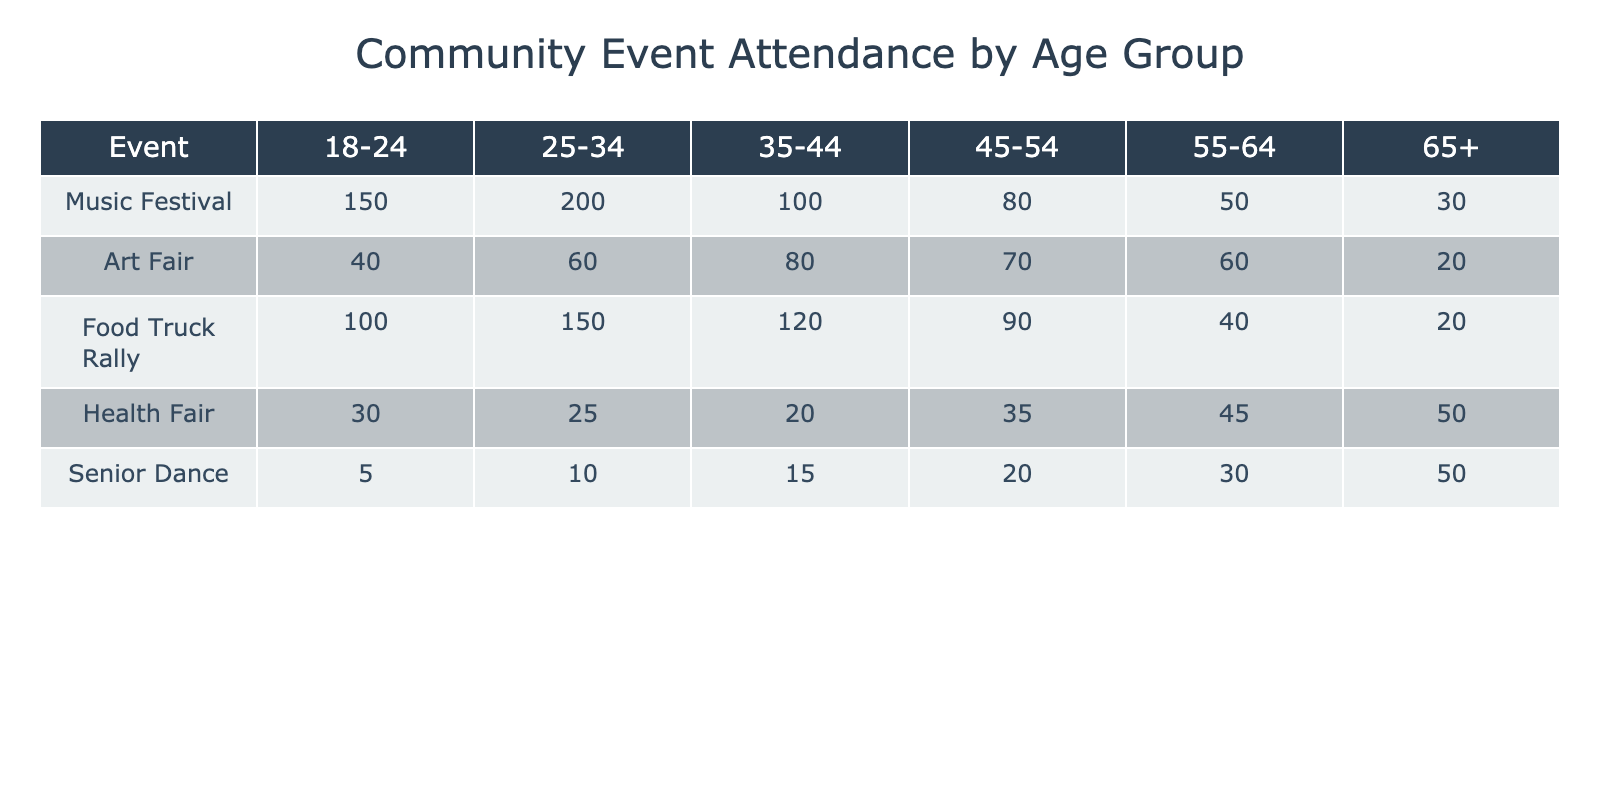What age group had the highest attendance at the Music Festival? Looking at the Music Festival column, the highest number is 200, which corresponds to the age group 25-34.
Answer: 25-34 How many attendees aged 45-54 participated in the Health Fair? The Health Fair column for the age group 45-54 shows an attendance of 35.
Answer: 35 What is the total attendance across all events for the age group 65+? By adding the values for the 65+ age group from all events: 30 + 20 + 20 + 50 + 50 = 170.
Answer: 170 Which event had the lowest attendance from the age group 18-24? In the 18-24 age group, the lowest attendance is for the Senior Dance with 5 attendees.
Answer: Senior Dance Did more people from the age group 55-64 attend the Food Truck Rally than the Art Fair? The Food Truck Rally attendance for 55-64 is 40, and for the Art Fair it is 60. Thus, 40 is less than 60.
Answer: No What is the average attendance for the Food Truck Rally across all age groups? To find the average: (100 + 150 + 120 + 90 + 40 + 20) = 520. There are 6 age groups, so the average is 520 / 6 ≈ 86.67.
Answer: 86.67 Which age group had the highest attendance at the Senior Dance event? The Senior Dance event had the highest attendance of 50 from the age group 65+.
Answer: 65+ What is the difference in attendance between the Art Fair and Health Fair for the age group 35-44? The attendance for the Art Fair in the 35-44 age group is 80, and for the Health Fair, it is 20. The difference is 80 - 20 = 60.
Answer: 60 Was the total attendance at the Music Festival for all age groups greater than 600? Adding the Music Festival attendance gives: 150 + 200 + 100 + 80 + 50 + 30 = 610, which is greater than 600.
Answer: Yes 